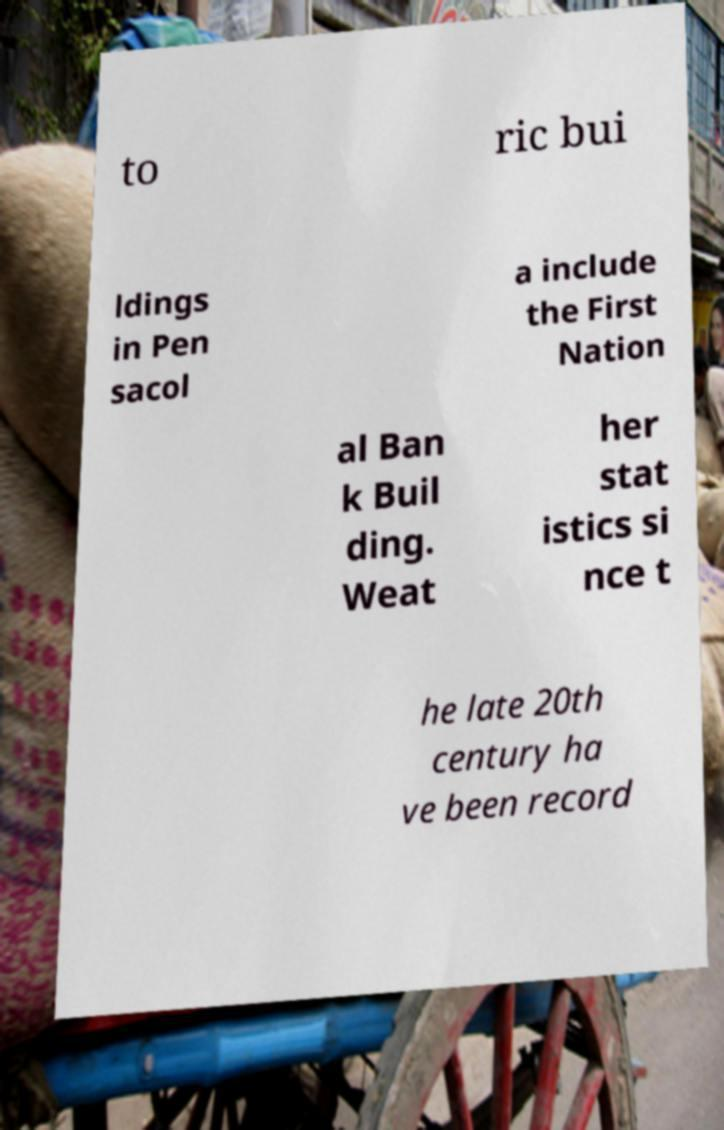Could you assist in decoding the text presented in this image and type it out clearly? to ric bui ldings in Pen sacol a include the First Nation al Ban k Buil ding. Weat her stat istics si nce t he late 20th century ha ve been record 